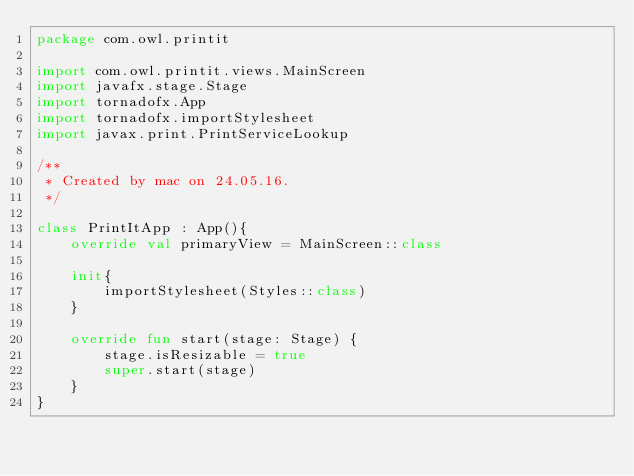Convert code to text. <code><loc_0><loc_0><loc_500><loc_500><_Kotlin_>package com.owl.printit

import com.owl.printit.views.MainScreen
import javafx.stage.Stage
import tornadofx.App
import tornadofx.importStylesheet
import javax.print.PrintServiceLookup

/**
 * Created by mac on 24.05.16.
 */

class PrintItApp : App(){
    override val primaryView = MainScreen::class

    init{
        importStylesheet(Styles::class)
    }

    override fun start(stage: Stage) {
        stage.isResizable = true
        super.start(stage)
    }
}

</code> 